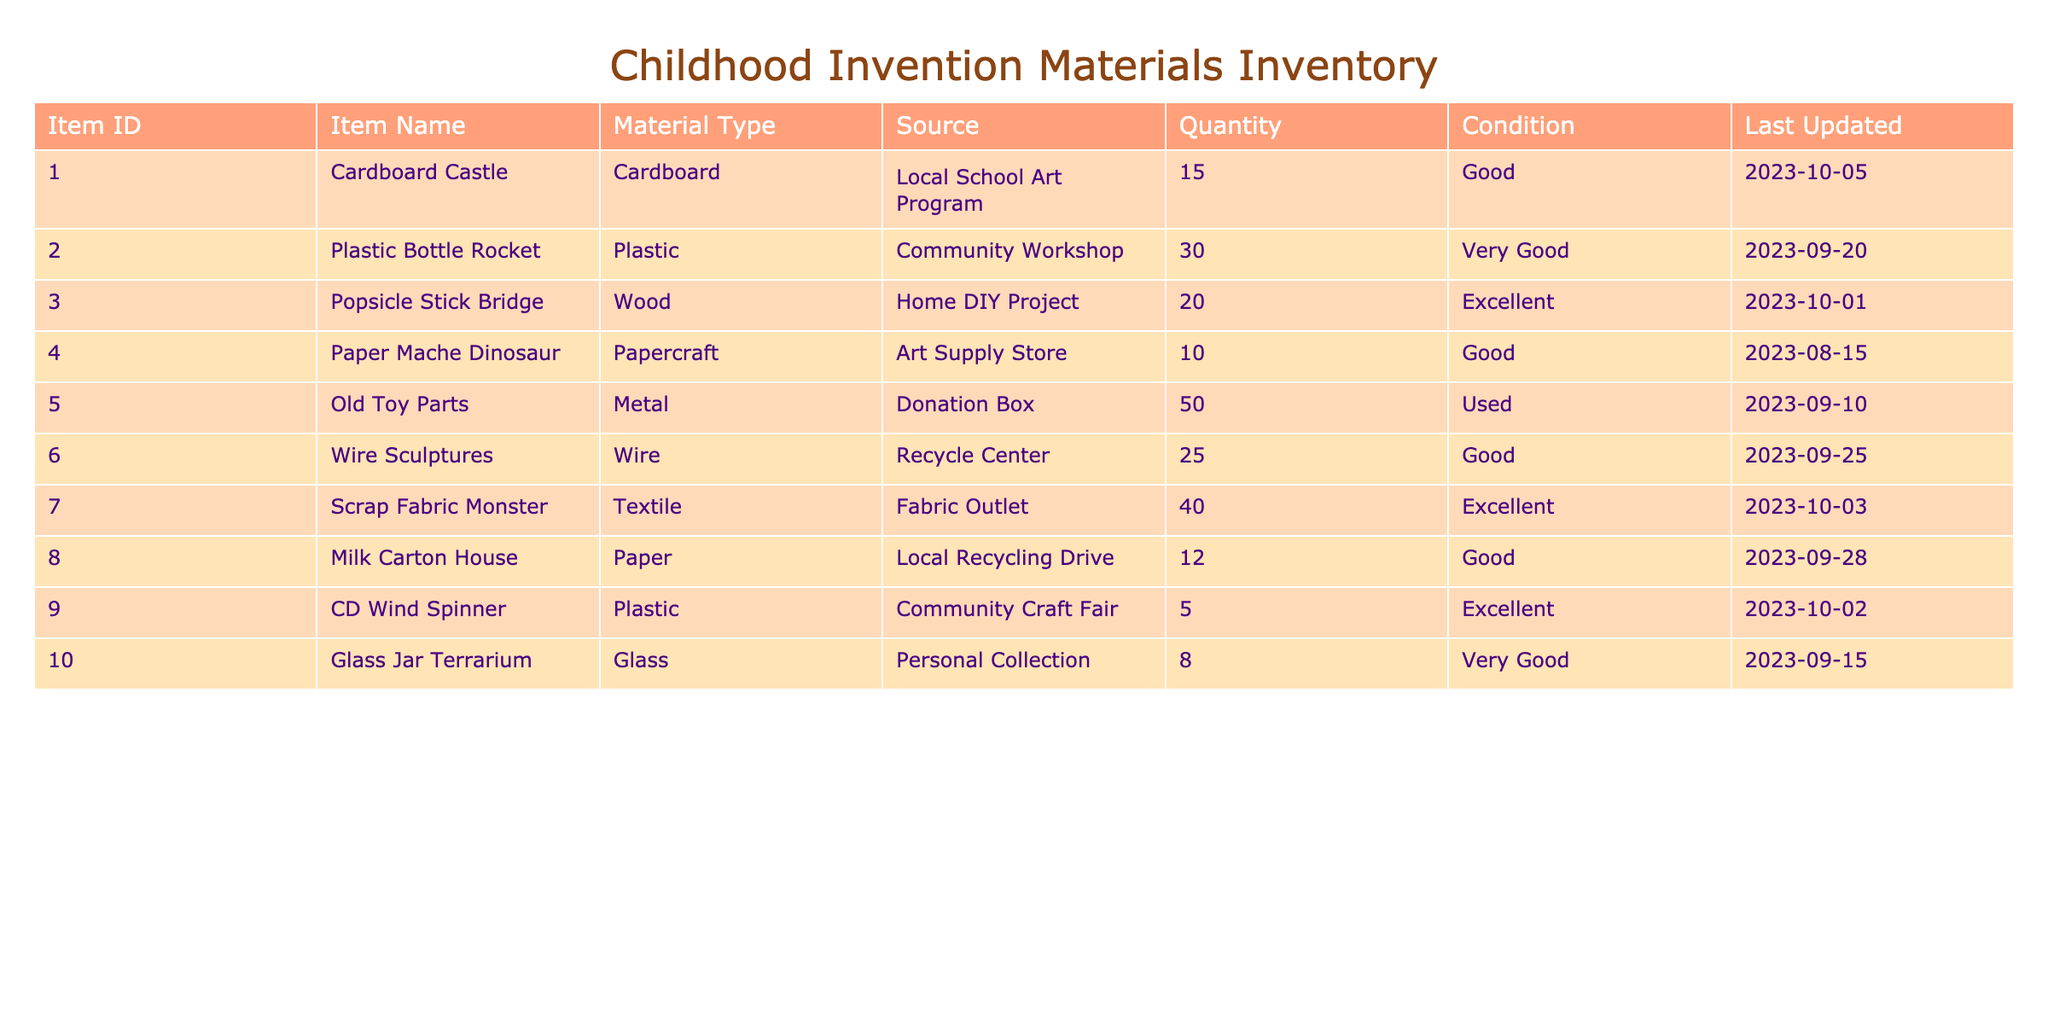What is the total quantity of Cardboard items in the inventory? The only Cardboard item listed is the Cardboard Castle, which has a quantity of 15. Therefore, the total quantity of Cardboard items is solely this value, as there are no other Cardboard items in the table.
Answer: 15 Which material type has the highest quantity in the inventory? To find this, I will compare the Quantity values across all material types. The Old Toy Parts (50) is the highest Quantity item, followed by Plastic Bottle Rocket (30), Scrap Fabric Monster (40), and then the rest. Old Toy Parts has the highest overall quantity among all items.
Answer: Metal Are there any items sourced from a donation? I will check the Source column for the word "Donation." The Old Toy Parts is sourced from a Donation Box, confirming the existence of at least one item sourced this way.
Answer: Yes What is the average quantity of items in excellent condition? The items listed in excellent condition are the Popsicle Stick Bridge (20), Scrap Fabric Monster (40), CD Wind Spinner (5), and the total quantity of these three items is 20 + 40 + 5 = 65. There are three items in excellent condition, so the average is 65/3 = 21.67.
Answer: 21.67 How many items have a quantity less than 10? By reviewing the Quantity column, I can observe that the only item with less than 10 is the Glass Jar Terrarium, with a quantity of 8. Therefore, there is only one item that falls below this threshold.
Answer: 1 What are the conditions of items that are sourced from community events? Items from community events include the Plastic Bottle Rocket (Very Good) from the Community Workshop and the CD Wind Spinner (Excellent) from the Community Craft Fair. Therefore, the conditions are Very Good and Excellent respectively.
Answer: Very Good, Excellent Is there a paper item that is in good condition? Reviewing the table, I see that both Paper Mache Dinosaur (Good) and Milk Carton House (Good) are in the Paper material type and are listed as being in good condition. Thus, there are at least two items that satisfy this condition.
Answer: Yes What is the total quantity of items made from wood? The only item made from wood is the Popsicle Stick Bridge, which has a quantity of 20, indicating that the total quantity of wooden items is just the quantity of this single item.
Answer: 20 Which items have a better condition than the Old Toy Parts? The Old Toy Parts are in Used condition. The items that are in better condition compared to this are: Cardboard Castle (Good), Plastic Bottle Rocket (Very Good), Popsicle Stick Bridge (Excellent), Paper Mache Dinosaur (Good), Wire Sculptures (Good), Scrap Fabric Monster (Excellent), Milk Carton House (Good), CD Wind Spinner (Excellent), and Glass Jar Terrarium (Very Good). There are a total of 8 items in better condition than the Old Toy Parts.
Answer: 8 